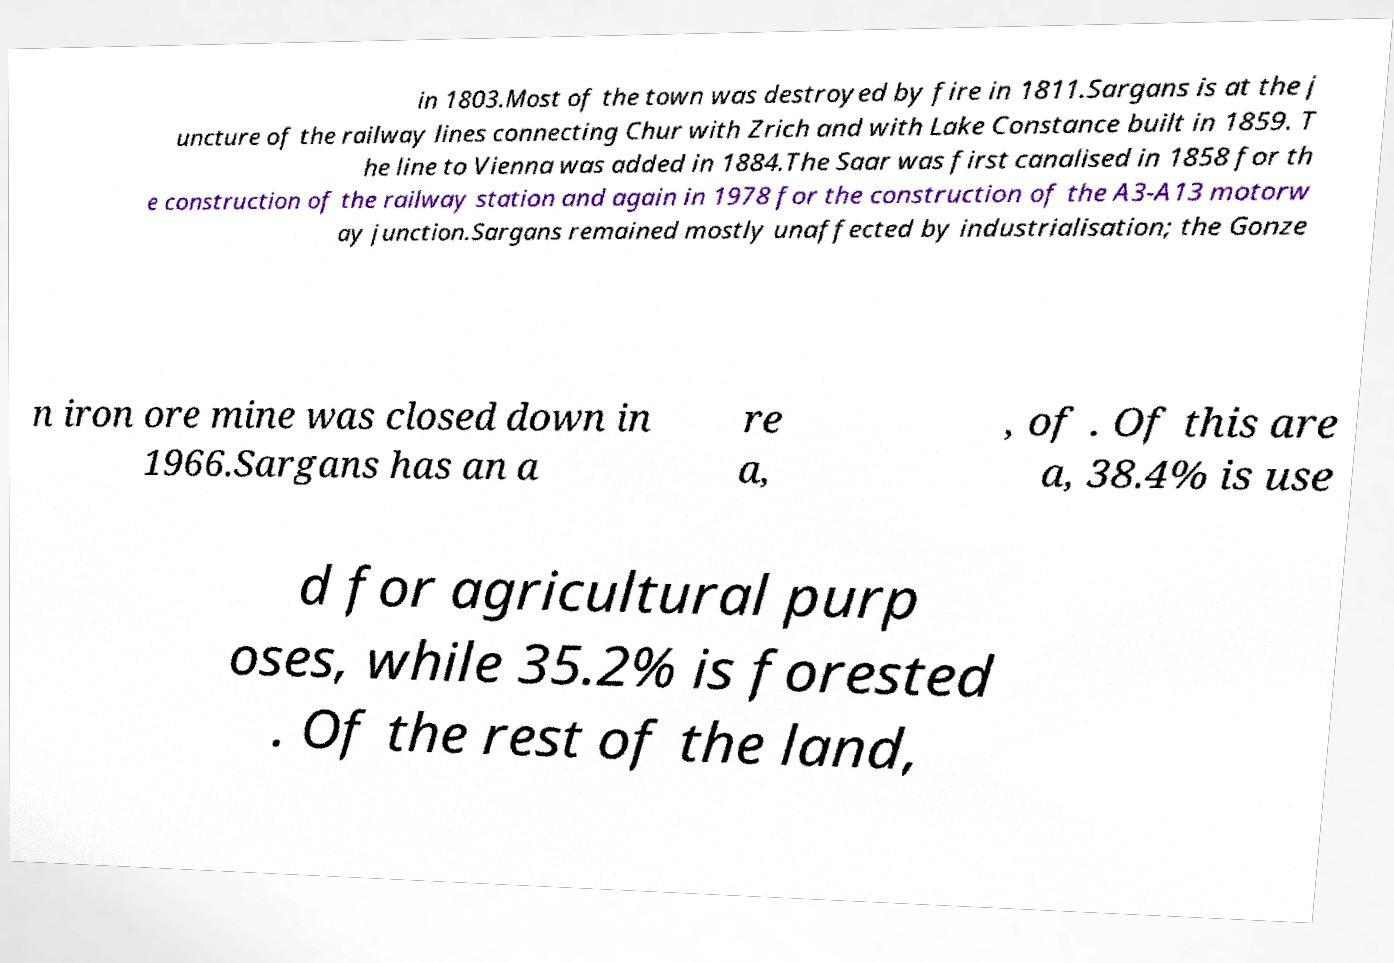For documentation purposes, I need the text within this image transcribed. Could you provide that? in 1803.Most of the town was destroyed by fire in 1811.Sargans is at the j uncture of the railway lines connecting Chur with Zrich and with Lake Constance built in 1859. T he line to Vienna was added in 1884.The Saar was first canalised in 1858 for th e construction of the railway station and again in 1978 for the construction of the A3-A13 motorw ay junction.Sargans remained mostly unaffected by industrialisation; the Gonze n iron ore mine was closed down in 1966.Sargans has an a re a, , of . Of this are a, 38.4% is use d for agricultural purp oses, while 35.2% is forested . Of the rest of the land, 